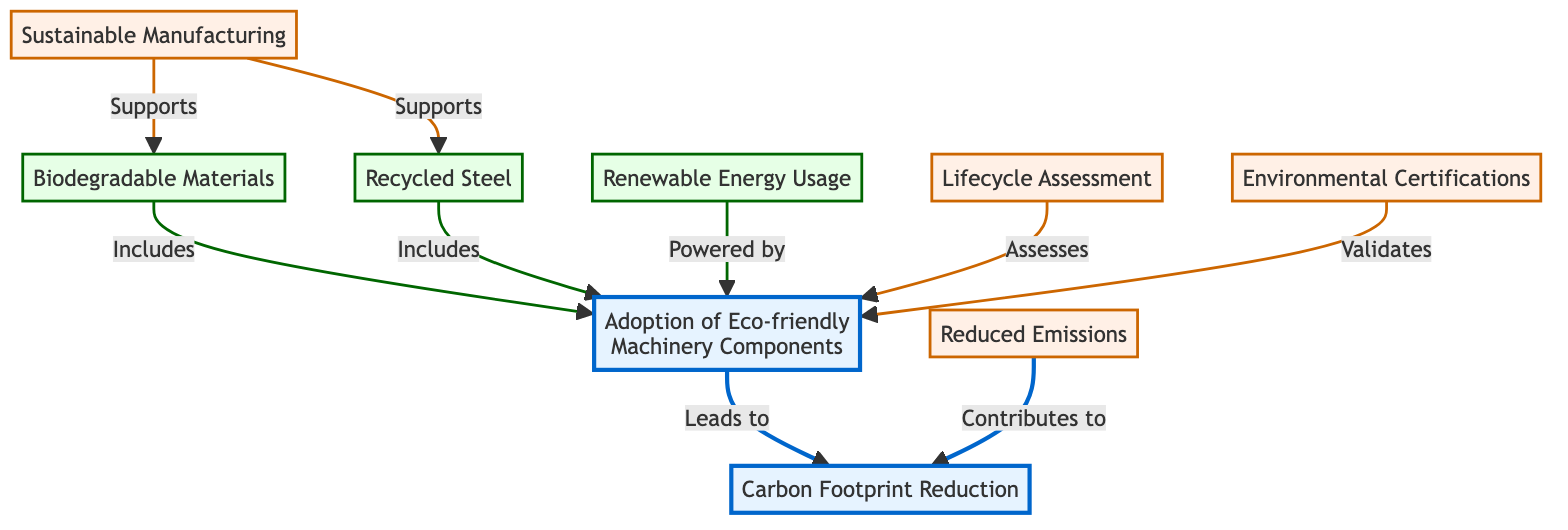What is the primary focus of the diagram? The diagram illustrates the concept of carbon footprint reduction, showing the importance of adopting eco-friendly machinery components. This is established by the main node labeled "Carbon Footprint Reduction," from which the process branches out.
Answer: Carbon Footprint Reduction How many eco-friendly components are listed in the diagram? The diagram features three eco-friendly components, specifically "Biodegradable Materials," "Recycled Steel," and "Renewable Energy Usage." These can be counted by identifying the nodes classified under eco.
Answer: Three What drives the adoption of eco-friendly machinery components? The adoption is driven primarily by the inclusion of "Biodegradable Materials" and "Recycled Steel," which are indicated as components leading to the main concept of carbon footprint reduction. The relationship can be traced through the arrows pointing towards the node "Adoption of Eco-friendly Machinery Components."
Answer: Biodegradable Materials and Recycled Steel Which component directly contributes to reduced emissions? The node labeled "Reduced Emissions" indicates an end result influenced by the adoption of eco-friendly machinery components, specifically the processes involved in their usage. The link shows that while other components support the main focus, this one is a direct outcome.
Answer: Reduced Emissions How does sustainable manufacturing relate to biodegradable materials? "Sustainable Manufacturing" supports both "Biodegradable Materials" and "Recycled Steel," indicating an intertwined relationship. Thus, the adoption of sustainable practices in manufacturing facilitates the use of biodegradable materials, forming a direct link in the diagram.
Answer: Supports What is assessed to validate the adoption of eco-friendly machinery components? The diagram indicates that "Lifecycle Assessment" is the method used to assess the overall impact of eco-friendly machinery components on carbon footprint reduction, showing that proper evaluation is essential for validation.
Answer: Lifecycle Assessment How many processes are listed that contribute to carbon footprint reduction? Four processes contribute to carbon footprint reduction: "Reduced Emissions," "Sustainable Manufacturing," "Lifecycle Assessment," and "Environmental Certifications." The total can be determined by counting the process nodes connected to the main concept.
Answer: Four Which two components are shown to support recycled steel? The nodes "Sustainable Manufacturing" and "Renewable Energy Usage" are shown to support "Recycled Steel," depicting a collaborative relationship where manufacturing practices and energy sources impact the recycling process effectively.
Answer: Sustainable Manufacturing and Renewable Energy Usage What is the relationship between environmental certifications and the adoption of eco-friendly components? "Environmental Certifications" validates the adoption of eco-friendly machinery components, indicating that attaining certifiable standards is an essential part of the adoption process illustrated in the diagram.
Answer: Validates 